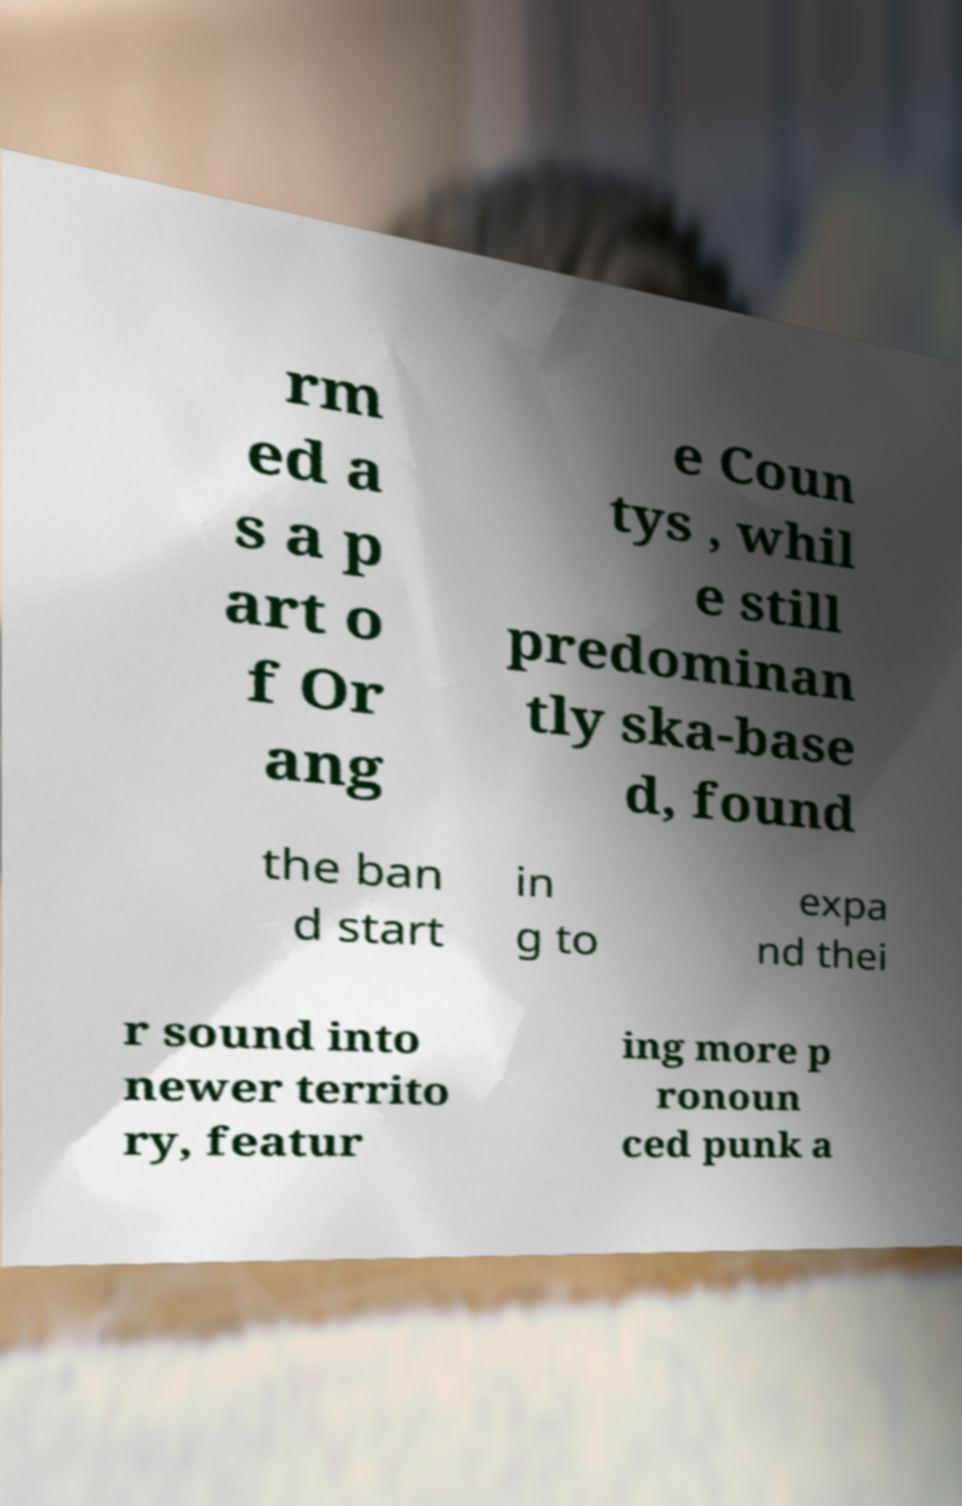For documentation purposes, I need the text within this image transcribed. Could you provide that? rm ed a s a p art o f Or ang e Coun tys , whil e still predominan tly ska-base d, found the ban d start in g to expa nd thei r sound into newer territo ry, featur ing more p ronoun ced punk a 